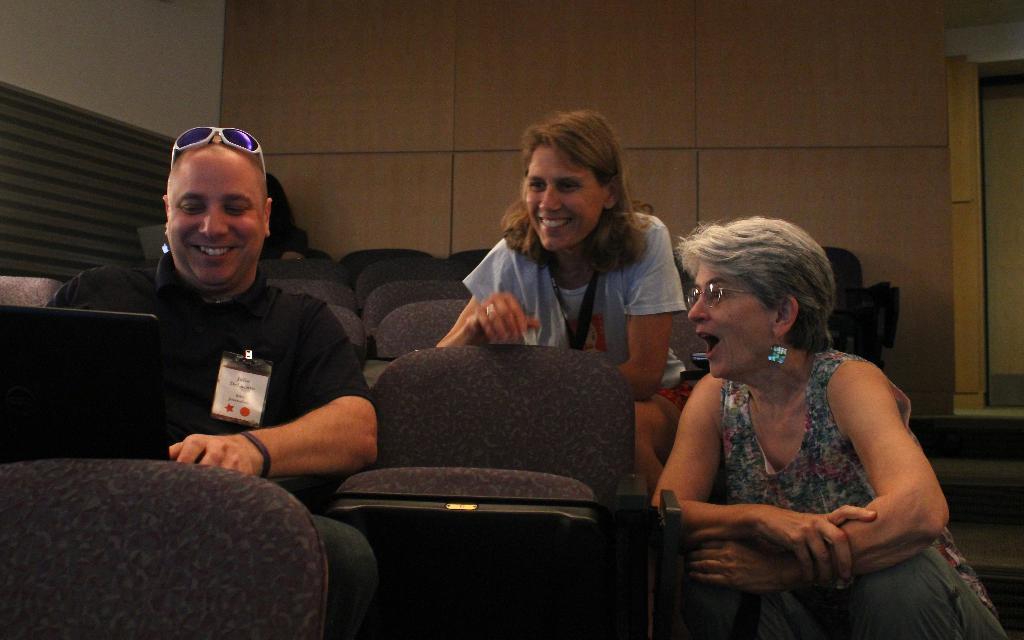Can you describe this image briefly? In this image we can see people sitting. There are chairs. In the background of the image there is wall. To the right side of the image there is a door. 